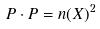Convert formula to latex. <formula><loc_0><loc_0><loc_500><loc_500>P \cdot P = n ( X ) ^ { 2 }</formula> 